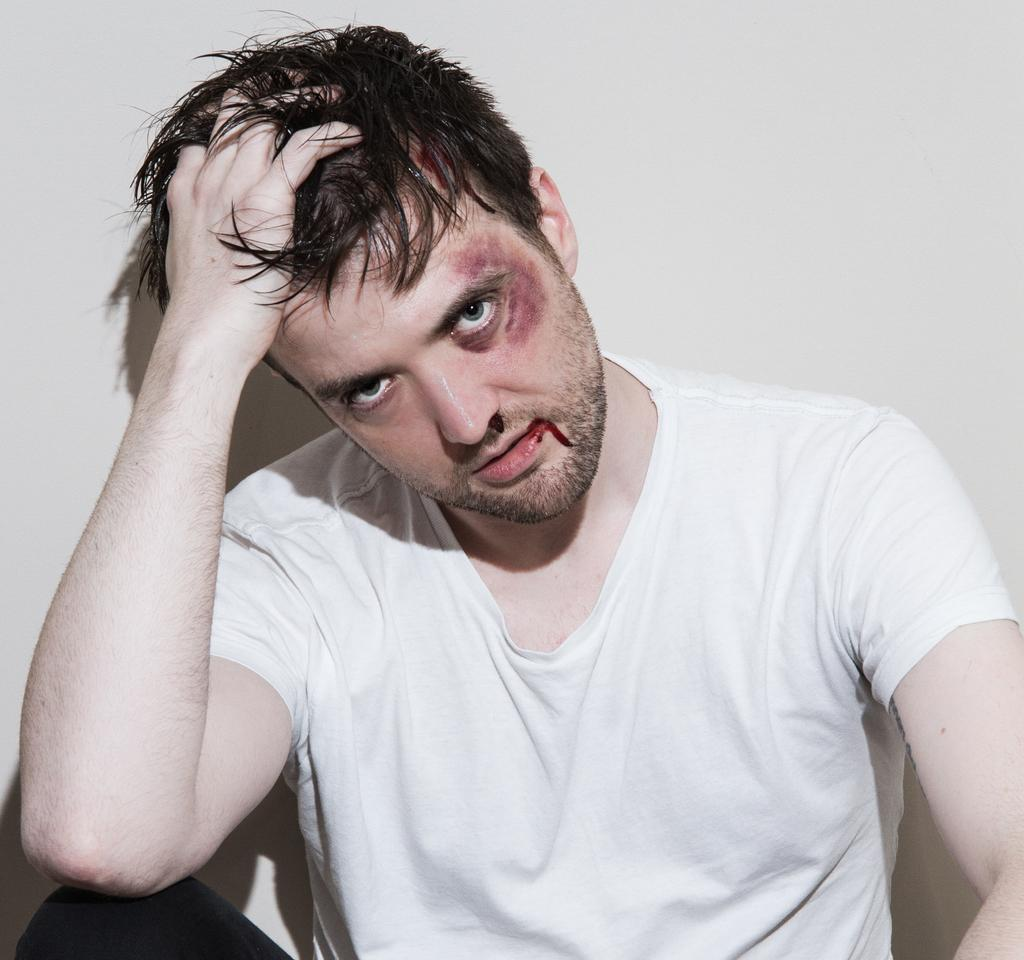What is the person in the image doing? There is a person sitting in the image. Can you describe the person's appearance? The person has an injury on their face. What is visible behind the person in the image? There is a wall behind the person. What type of amusement can be seen in the image? There is no amusement present in the image; it features a person sitting with an injury on their face and a wall behind them. Can you provide a suggestion for the person in the image? We cannot provide a suggestion for the person in the image, as we are only looking at the image and not offering advice. 